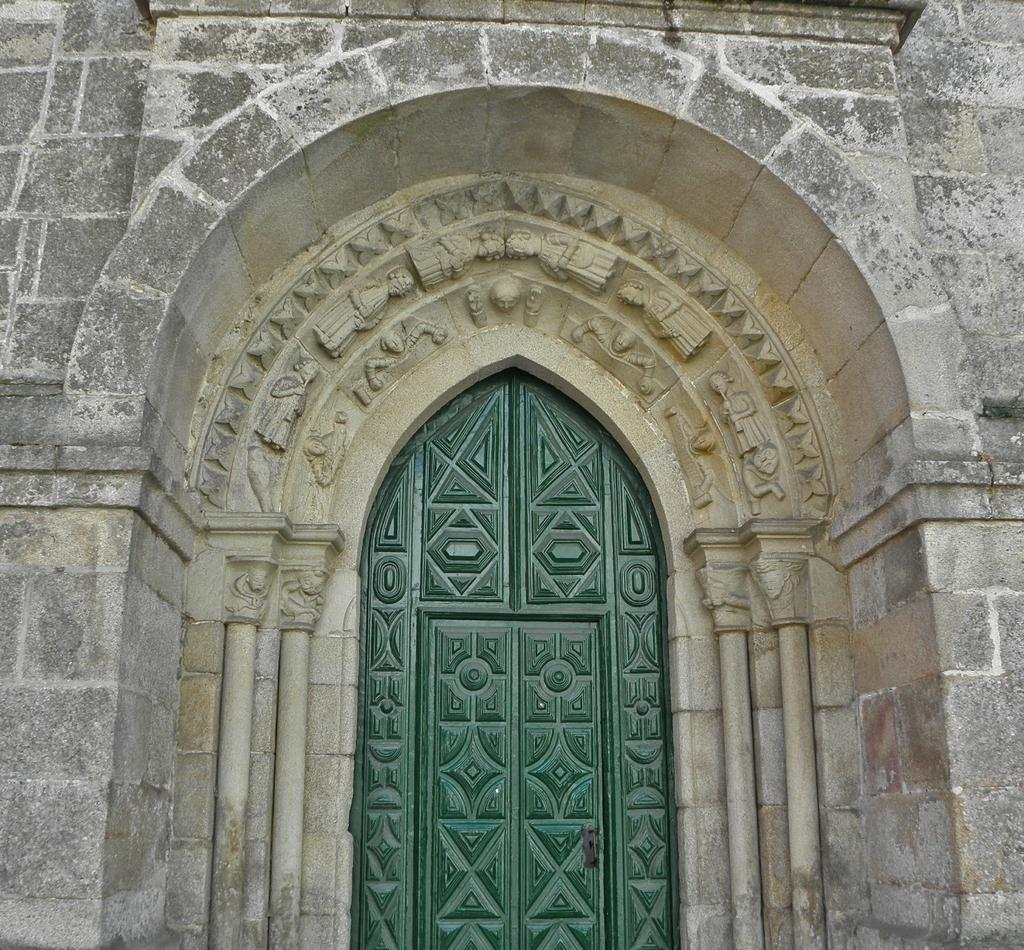What type of structure is visible in the image? There is a wall and an arch in the image. How are the wall and the arch related in the image? The arch is connected to the wall in the image. What feature is present within the arch? There is a door inside the arch in the image. What type of stream can be seen flowing through the arch in the image? There is no stream present in the image; it only features a wall, an arch, and a door. What substance is being used to write on the wall in the image? There is no writing or substance visible on the wall in the image. 